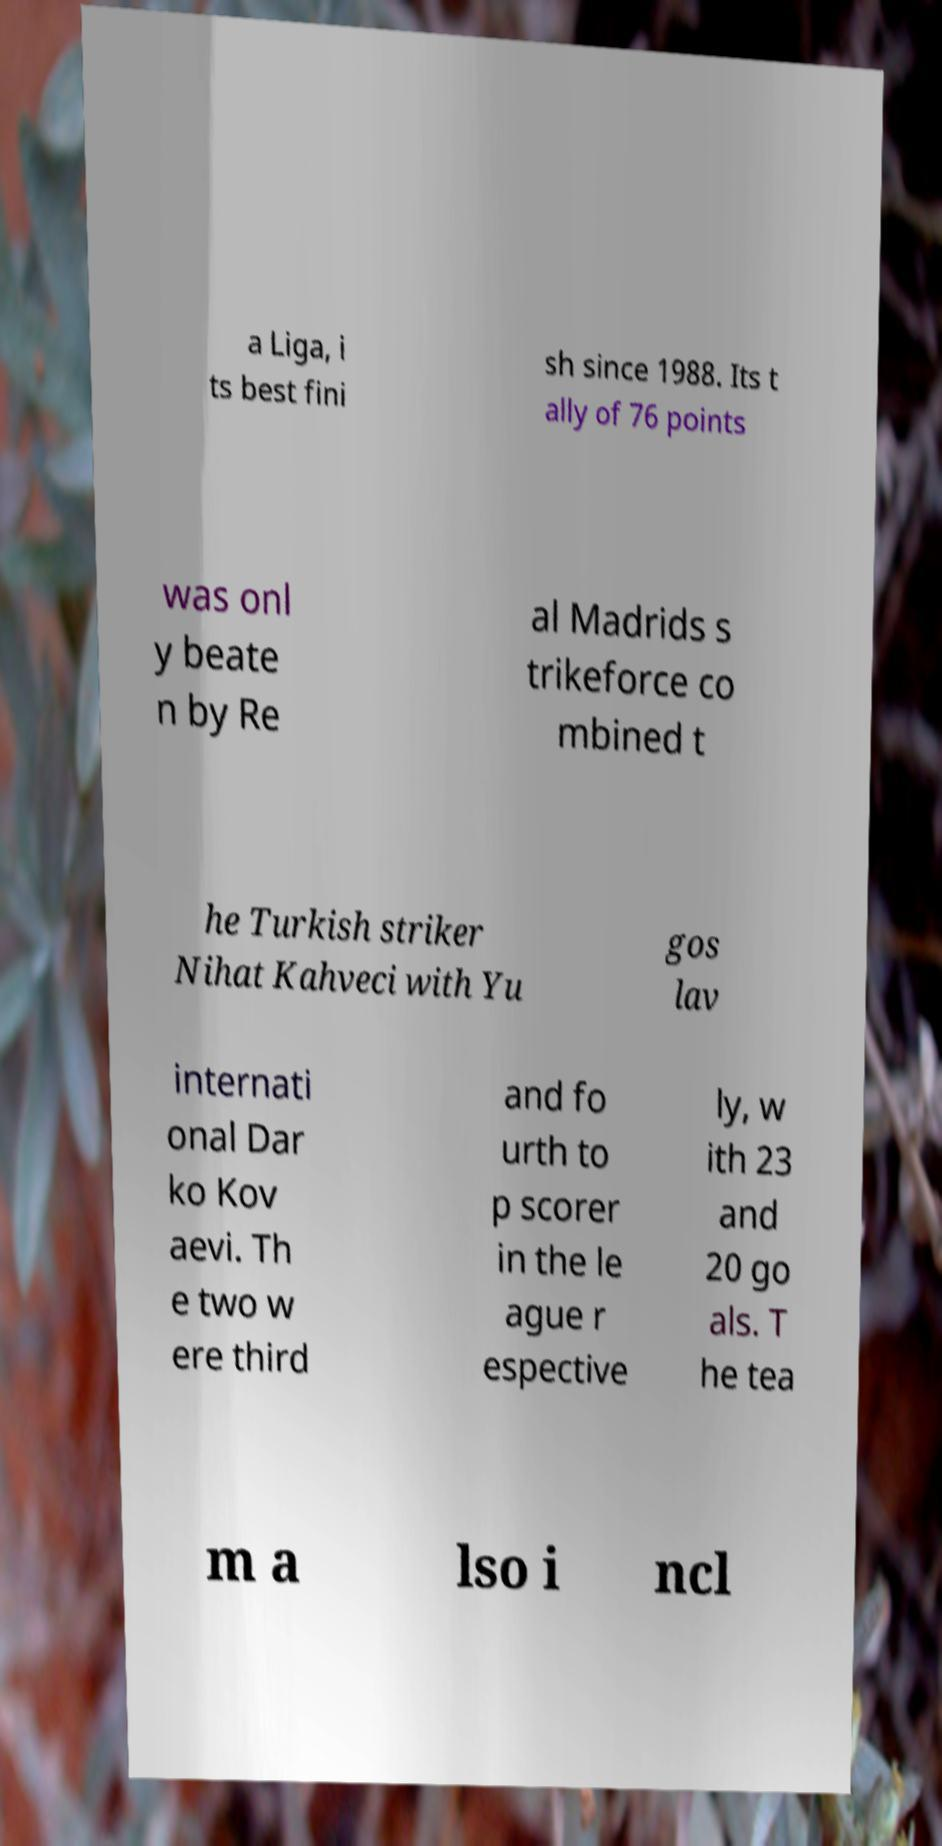Could you assist in decoding the text presented in this image and type it out clearly? a Liga, i ts best fini sh since 1988. Its t ally of 76 points was onl y beate n by Re al Madrids s trikeforce co mbined t he Turkish striker Nihat Kahveci with Yu gos lav internati onal Dar ko Kov aevi. Th e two w ere third and fo urth to p scorer in the le ague r espective ly, w ith 23 and 20 go als. T he tea m a lso i ncl 